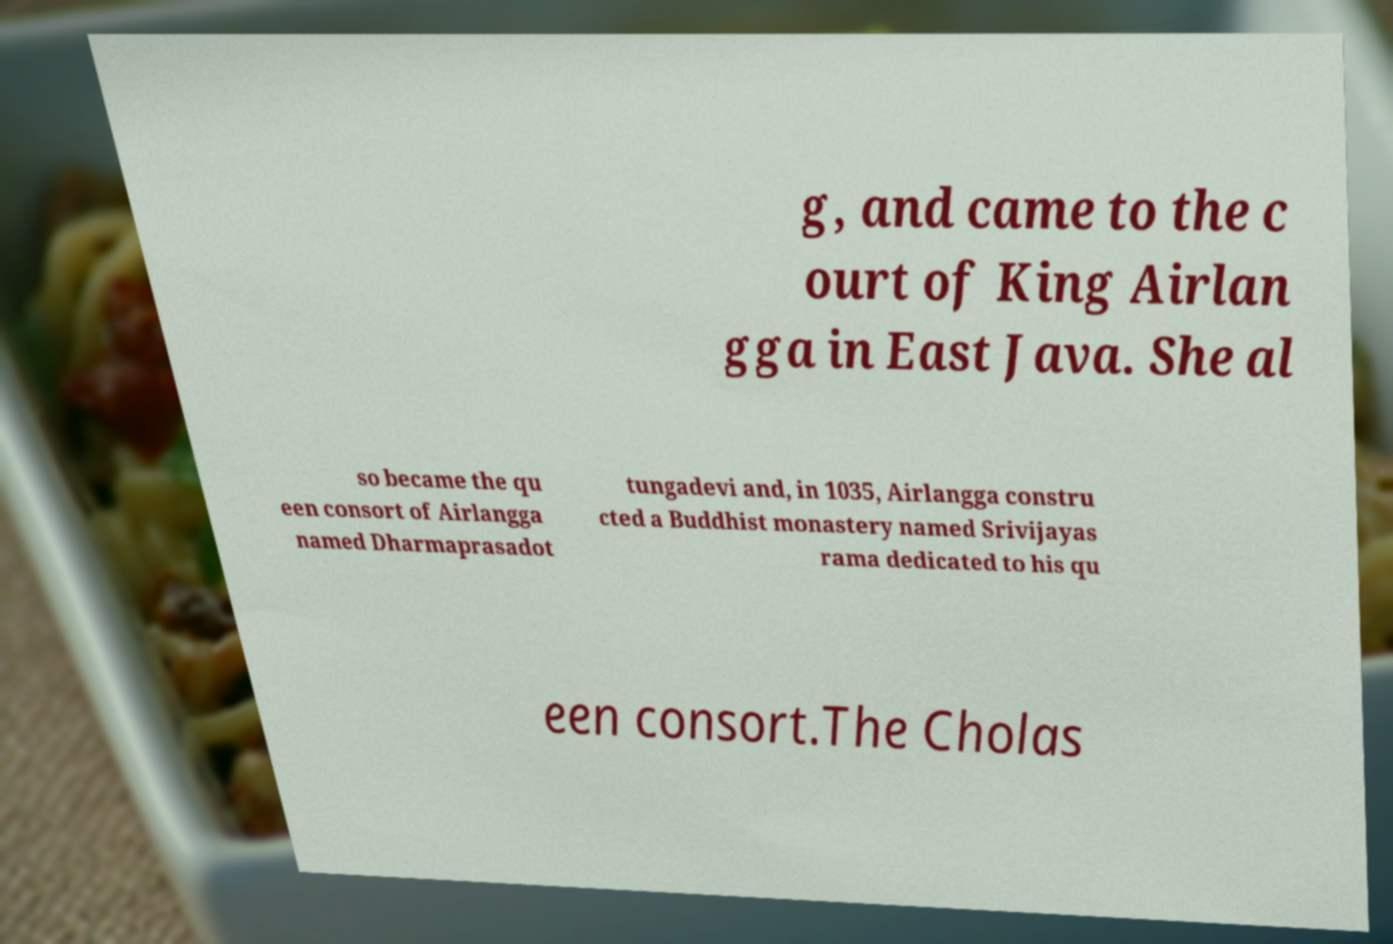I need the written content from this picture converted into text. Can you do that? g, and came to the c ourt of King Airlan gga in East Java. She al so became the qu een consort of Airlangga named Dharmaprasadot tungadevi and, in 1035, Airlangga constru cted a Buddhist monastery named Srivijayas rama dedicated to his qu een consort.The Cholas 